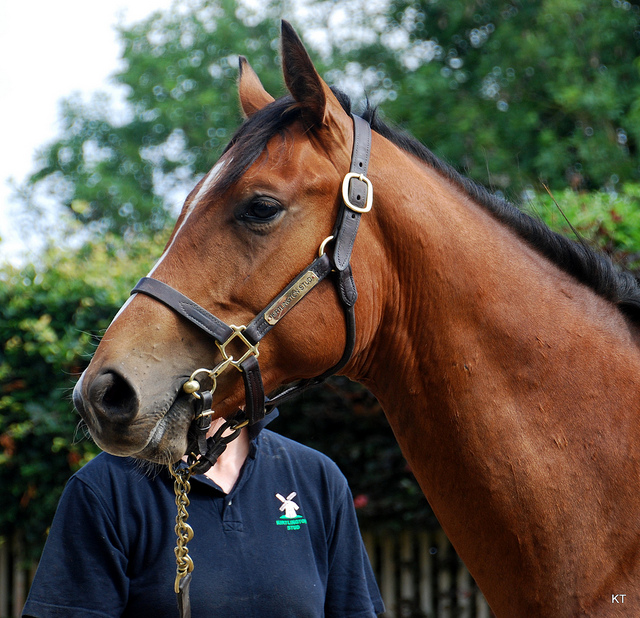Please transcribe the text in this image. KT 